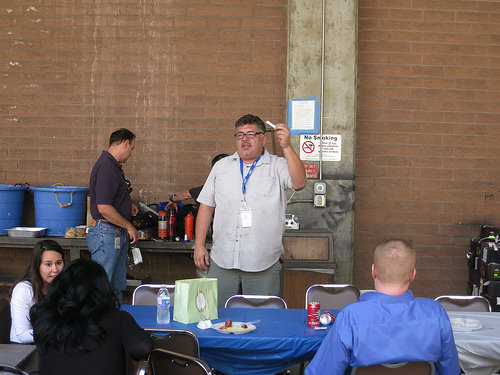<image>
Is there a brick wall behind the man? Yes. From this viewpoint, the brick wall is positioned behind the man, with the man partially or fully occluding the brick wall. Is the man behind the table? Yes. From this viewpoint, the man is positioned behind the table, with the table partially or fully occluding the man. 